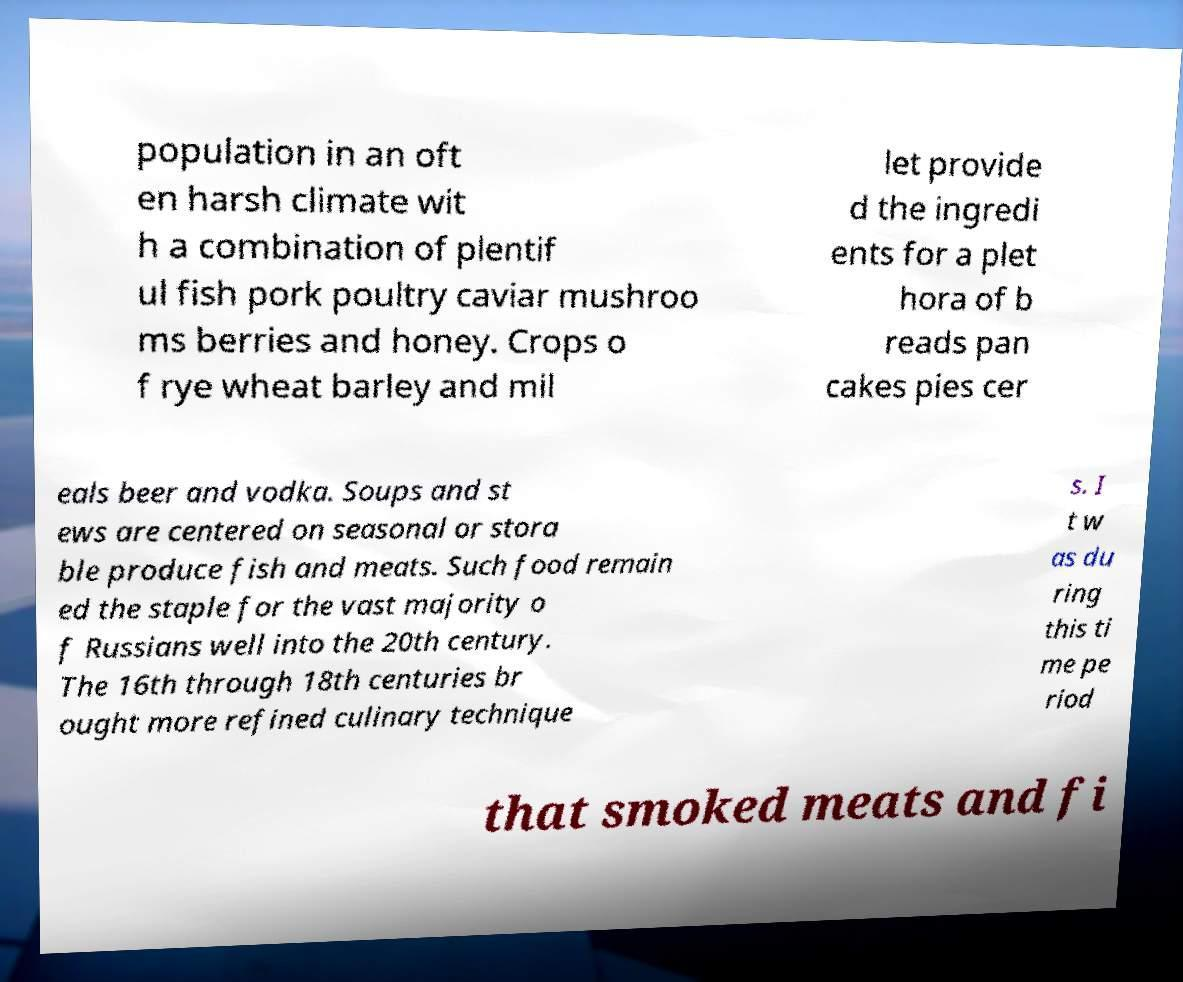Can you accurately transcribe the text from the provided image for me? population in an oft en harsh climate wit h a combination of plentif ul fish pork poultry caviar mushroo ms berries and honey. Crops o f rye wheat barley and mil let provide d the ingredi ents for a plet hora of b reads pan cakes pies cer eals beer and vodka. Soups and st ews are centered on seasonal or stora ble produce fish and meats. Such food remain ed the staple for the vast majority o f Russians well into the 20th century. The 16th through 18th centuries br ought more refined culinary technique s. I t w as du ring this ti me pe riod that smoked meats and fi 